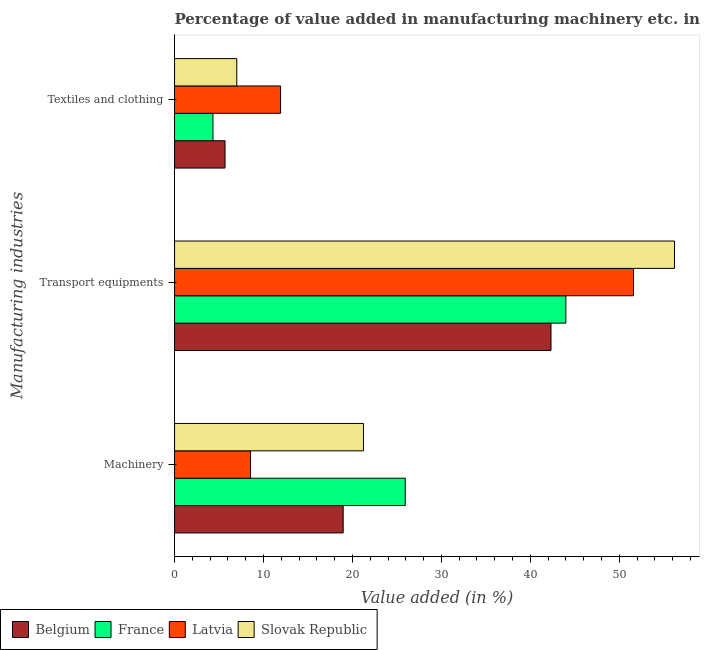How many different coloured bars are there?
Ensure brevity in your answer.  4. How many groups of bars are there?
Provide a succinct answer. 3. Are the number of bars per tick equal to the number of legend labels?
Ensure brevity in your answer.  Yes. How many bars are there on the 2nd tick from the bottom?
Offer a very short reply. 4. What is the label of the 2nd group of bars from the top?
Your response must be concise. Transport equipments. What is the value added in manufacturing machinery in Slovak Republic?
Give a very brief answer. 21.25. Across all countries, what is the maximum value added in manufacturing transport equipments?
Provide a short and direct response. 56.21. Across all countries, what is the minimum value added in manufacturing textile and clothing?
Offer a very short reply. 4.32. In which country was the value added in manufacturing transport equipments maximum?
Make the answer very short. Slovak Republic. In which country was the value added in manufacturing transport equipments minimum?
Provide a short and direct response. Belgium. What is the total value added in manufacturing textile and clothing in the graph?
Keep it short and to the point. 28.92. What is the difference between the value added in manufacturing textile and clothing in Latvia and that in France?
Keep it short and to the point. 7.6. What is the difference between the value added in manufacturing transport equipments in France and the value added in manufacturing textile and clothing in Belgium?
Provide a short and direct response. 38.32. What is the average value added in manufacturing machinery per country?
Offer a very short reply. 18.67. What is the difference between the value added in manufacturing textile and clothing and value added in manufacturing transport equipments in Belgium?
Your answer should be very brief. -36.65. In how many countries, is the value added in manufacturing textile and clothing greater than 48 %?
Make the answer very short. 0. What is the ratio of the value added in manufacturing textile and clothing in Latvia to that in Belgium?
Keep it short and to the point. 2.1. What is the difference between the highest and the second highest value added in manufacturing machinery?
Offer a terse response. 4.69. What is the difference between the highest and the lowest value added in manufacturing machinery?
Keep it short and to the point. 17.39. Is the sum of the value added in manufacturing textile and clothing in Latvia and Belgium greater than the maximum value added in manufacturing transport equipments across all countries?
Offer a terse response. No. What does the 4th bar from the top in Textiles and clothing represents?
Keep it short and to the point. Belgium. What does the 1st bar from the bottom in Textiles and clothing represents?
Give a very brief answer. Belgium. Is it the case that in every country, the sum of the value added in manufacturing machinery and value added in manufacturing transport equipments is greater than the value added in manufacturing textile and clothing?
Your answer should be compact. Yes. How many bars are there?
Provide a succinct answer. 12. Are all the bars in the graph horizontal?
Make the answer very short. Yes. How many countries are there in the graph?
Provide a succinct answer. 4. Are the values on the major ticks of X-axis written in scientific E-notation?
Your answer should be very brief. No. Does the graph contain grids?
Offer a very short reply. No. Where does the legend appear in the graph?
Your answer should be very brief. Bottom left. How many legend labels are there?
Offer a very short reply. 4. What is the title of the graph?
Make the answer very short. Percentage of value added in manufacturing machinery etc. in countries. What is the label or title of the X-axis?
Your answer should be compact. Value added (in %). What is the label or title of the Y-axis?
Offer a very short reply. Manufacturing industries. What is the Value added (in %) in Belgium in Machinery?
Provide a succinct answer. 18.96. What is the Value added (in %) of France in Machinery?
Your response must be concise. 25.94. What is the Value added (in %) of Latvia in Machinery?
Provide a short and direct response. 8.54. What is the Value added (in %) in Slovak Republic in Machinery?
Keep it short and to the point. 21.25. What is the Value added (in %) in Belgium in Transport equipments?
Your response must be concise. 42.32. What is the Value added (in %) in France in Transport equipments?
Give a very brief answer. 44. What is the Value added (in %) of Latvia in Transport equipments?
Your answer should be compact. 51.6. What is the Value added (in %) in Slovak Republic in Transport equipments?
Offer a very short reply. 56.21. What is the Value added (in %) of Belgium in Textiles and clothing?
Offer a very short reply. 5.68. What is the Value added (in %) of France in Textiles and clothing?
Your answer should be compact. 4.32. What is the Value added (in %) in Latvia in Textiles and clothing?
Make the answer very short. 11.92. What is the Value added (in %) in Slovak Republic in Textiles and clothing?
Offer a very short reply. 7. Across all Manufacturing industries, what is the maximum Value added (in %) in Belgium?
Offer a very short reply. 42.32. Across all Manufacturing industries, what is the maximum Value added (in %) of France?
Provide a succinct answer. 44. Across all Manufacturing industries, what is the maximum Value added (in %) of Latvia?
Keep it short and to the point. 51.6. Across all Manufacturing industries, what is the maximum Value added (in %) in Slovak Republic?
Your answer should be very brief. 56.21. Across all Manufacturing industries, what is the minimum Value added (in %) of Belgium?
Your answer should be very brief. 5.68. Across all Manufacturing industries, what is the minimum Value added (in %) in France?
Provide a short and direct response. 4.32. Across all Manufacturing industries, what is the minimum Value added (in %) in Latvia?
Offer a very short reply. 8.54. Across all Manufacturing industries, what is the minimum Value added (in %) of Slovak Republic?
Offer a very short reply. 7. What is the total Value added (in %) in Belgium in the graph?
Provide a succinct answer. 66.96. What is the total Value added (in %) of France in the graph?
Ensure brevity in your answer.  74.26. What is the total Value added (in %) in Latvia in the graph?
Ensure brevity in your answer.  72.06. What is the total Value added (in %) in Slovak Republic in the graph?
Your answer should be compact. 84.45. What is the difference between the Value added (in %) in Belgium in Machinery and that in Transport equipments?
Your response must be concise. -23.37. What is the difference between the Value added (in %) in France in Machinery and that in Transport equipments?
Your answer should be very brief. -18.06. What is the difference between the Value added (in %) of Latvia in Machinery and that in Transport equipments?
Offer a terse response. -43.05. What is the difference between the Value added (in %) in Slovak Republic in Machinery and that in Transport equipments?
Provide a short and direct response. -34.96. What is the difference between the Value added (in %) of Belgium in Machinery and that in Textiles and clothing?
Ensure brevity in your answer.  13.28. What is the difference between the Value added (in %) in France in Machinery and that in Textiles and clothing?
Offer a terse response. 21.62. What is the difference between the Value added (in %) of Latvia in Machinery and that in Textiles and clothing?
Make the answer very short. -3.38. What is the difference between the Value added (in %) in Slovak Republic in Machinery and that in Textiles and clothing?
Your response must be concise. 14.25. What is the difference between the Value added (in %) in Belgium in Transport equipments and that in Textiles and clothing?
Ensure brevity in your answer.  36.65. What is the difference between the Value added (in %) of France in Transport equipments and that in Textiles and clothing?
Your answer should be compact. 39.68. What is the difference between the Value added (in %) in Latvia in Transport equipments and that in Textiles and clothing?
Your response must be concise. 39.67. What is the difference between the Value added (in %) in Slovak Republic in Transport equipments and that in Textiles and clothing?
Your response must be concise. 49.21. What is the difference between the Value added (in %) in Belgium in Machinery and the Value added (in %) in France in Transport equipments?
Your answer should be very brief. -25.04. What is the difference between the Value added (in %) of Belgium in Machinery and the Value added (in %) of Latvia in Transport equipments?
Your answer should be very brief. -32.64. What is the difference between the Value added (in %) in Belgium in Machinery and the Value added (in %) in Slovak Republic in Transport equipments?
Your answer should be compact. -37.25. What is the difference between the Value added (in %) in France in Machinery and the Value added (in %) in Latvia in Transport equipments?
Your answer should be very brief. -25.66. What is the difference between the Value added (in %) of France in Machinery and the Value added (in %) of Slovak Republic in Transport equipments?
Provide a short and direct response. -30.27. What is the difference between the Value added (in %) of Latvia in Machinery and the Value added (in %) of Slovak Republic in Transport equipments?
Make the answer very short. -47.66. What is the difference between the Value added (in %) in Belgium in Machinery and the Value added (in %) in France in Textiles and clothing?
Offer a very short reply. 14.64. What is the difference between the Value added (in %) of Belgium in Machinery and the Value added (in %) of Latvia in Textiles and clothing?
Provide a short and direct response. 7.04. What is the difference between the Value added (in %) of Belgium in Machinery and the Value added (in %) of Slovak Republic in Textiles and clothing?
Offer a very short reply. 11.96. What is the difference between the Value added (in %) in France in Machinery and the Value added (in %) in Latvia in Textiles and clothing?
Offer a terse response. 14.02. What is the difference between the Value added (in %) in France in Machinery and the Value added (in %) in Slovak Republic in Textiles and clothing?
Make the answer very short. 18.94. What is the difference between the Value added (in %) of Latvia in Machinery and the Value added (in %) of Slovak Republic in Textiles and clothing?
Your answer should be very brief. 1.55. What is the difference between the Value added (in %) in Belgium in Transport equipments and the Value added (in %) in France in Textiles and clothing?
Give a very brief answer. 38.01. What is the difference between the Value added (in %) of Belgium in Transport equipments and the Value added (in %) of Latvia in Textiles and clothing?
Your response must be concise. 30.4. What is the difference between the Value added (in %) of Belgium in Transport equipments and the Value added (in %) of Slovak Republic in Textiles and clothing?
Provide a succinct answer. 35.33. What is the difference between the Value added (in %) of France in Transport equipments and the Value added (in %) of Latvia in Textiles and clothing?
Your answer should be very brief. 32.08. What is the difference between the Value added (in %) in France in Transport equipments and the Value added (in %) in Slovak Republic in Textiles and clothing?
Offer a very short reply. 37. What is the difference between the Value added (in %) of Latvia in Transport equipments and the Value added (in %) of Slovak Republic in Textiles and clothing?
Make the answer very short. 44.6. What is the average Value added (in %) of Belgium per Manufacturing industries?
Offer a terse response. 22.32. What is the average Value added (in %) of France per Manufacturing industries?
Your answer should be very brief. 24.75. What is the average Value added (in %) of Latvia per Manufacturing industries?
Offer a very short reply. 24.02. What is the average Value added (in %) of Slovak Republic per Manufacturing industries?
Provide a succinct answer. 28.15. What is the difference between the Value added (in %) in Belgium and Value added (in %) in France in Machinery?
Make the answer very short. -6.98. What is the difference between the Value added (in %) in Belgium and Value added (in %) in Latvia in Machinery?
Give a very brief answer. 10.41. What is the difference between the Value added (in %) in Belgium and Value added (in %) in Slovak Republic in Machinery?
Make the answer very short. -2.29. What is the difference between the Value added (in %) in France and Value added (in %) in Latvia in Machinery?
Offer a very short reply. 17.39. What is the difference between the Value added (in %) in France and Value added (in %) in Slovak Republic in Machinery?
Your answer should be compact. 4.69. What is the difference between the Value added (in %) in Latvia and Value added (in %) in Slovak Republic in Machinery?
Make the answer very short. -12.7. What is the difference between the Value added (in %) in Belgium and Value added (in %) in France in Transport equipments?
Your answer should be very brief. -1.67. What is the difference between the Value added (in %) in Belgium and Value added (in %) in Latvia in Transport equipments?
Give a very brief answer. -9.27. What is the difference between the Value added (in %) in Belgium and Value added (in %) in Slovak Republic in Transport equipments?
Your answer should be compact. -13.88. What is the difference between the Value added (in %) of France and Value added (in %) of Latvia in Transport equipments?
Offer a very short reply. -7.6. What is the difference between the Value added (in %) in France and Value added (in %) in Slovak Republic in Transport equipments?
Make the answer very short. -12.21. What is the difference between the Value added (in %) in Latvia and Value added (in %) in Slovak Republic in Transport equipments?
Keep it short and to the point. -4.61. What is the difference between the Value added (in %) in Belgium and Value added (in %) in France in Textiles and clothing?
Provide a short and direct response. 1.36. What is the difference between the Value added (in %) in Belgium and Value added (in %) in Latvia in Textiles and clothing?
Provide a short and direct response. -6.24. What is the difference between the Value added (in %) of Belgium and Value added (in %) of Slovak Republic in Textiles and clothing?
Provide a succinct answer. -1.32. What is the difference between the Value added (in %) of France and Value added (in %) of Latvia in Textiles and clothing?
Provide a succinct answer. -7.6. What is the difference between the Value added (in %) in France and Value added (in %) in Slovak Republic in Textiles and clothing?
Keep it short and to the point. -2.68. What is the difference between the Value added (in %) of Latvia and Value added (in %) of Slovak Republic in Textiles and clothing?
Provide a succinct answer. 4.92. What is the ratio of the Value added (in %) in Belgium in Machinery to that in Transport equipments?
Your answer should be compact. 0.45. What is the ratio of the Value added (in %) of France in Machinery to that in Transport equipments?
Your response must be concise. 0.59. What is the ratio of the Value added (in %) of Latvia in Machinery to that in Transport equipments?
Ensure brevity in your answer.  0.17. What is the ratio of the Value added (in %) in Slovak Republic in Machinery to that in Transport equipments?
Your answer should be compact. 0.38. What is the ratio of the Value added (in %) of Belgium in Machinery to that in Textiles and clothing?
Your answer should be compact. 3.34. What is the ratio of the Value added (in %) of France in Machinery to that in Textiles and clothing?
Your response must be concise. 6.01. What is the ratio of the Value added (in %) of Latvia in Machinery to that in Textiles and clothing?
Your answer should be very brief. 0.72. What is the ratio of the Value added (in %) in Slovak Republic in Machinery to that in Textiles and clothing?
Make the answer very short. 3.04. What is the ratio of the Value added (in %) in Belgium in Transport equipments to that in Textiles and clothing?
Keep it short and to the point. 7.46. What is the ratio of the Value added (in %) of France in Transport equipments to that in Textiles and clothing?
Keep it short and to the point. 10.19. What is the ratio of the Value added (in %) of Latvia in Transport equipments to that in Textiles and clothing?
Your answer should be very brief. 4.33. What is the ratio of the Value added (in %) of Slovak Republic in Transport equipments to that in Textiles and clothing?
Give a very brief answer. 8.03. What is the difference between the highest and the second highest Value added (in %) of Belgium?
Keep it short and to the point. 23.37. What is the difference between the highest and the second highest Value added (in %) of France?
Give a very brief answer. 18.06. What is the difference between the highest and the second highest Value added (in %) in Latvia?
Make the answer very short. 39.67. What is the difference between the highest and the second highest Value added (in %) of Slovak Republic?
Provide a short and direct response. 34.96. What is the difference between the highest and the lowest Value added (in %) in Belgium?
Keep it short and to the point. 36.65. What is the difference between the highest and the lowest Value added (in %) in France?
Offer a very short reply. 39.68. What is the difference between the highest and the lowest Value added (in %) of Latvia?
Provide a succinct answer. 43.05. What is the difference between the highest and the lowest Value added (in %) of Slovak Republic?
Provide a short and direct response. 49.21. 